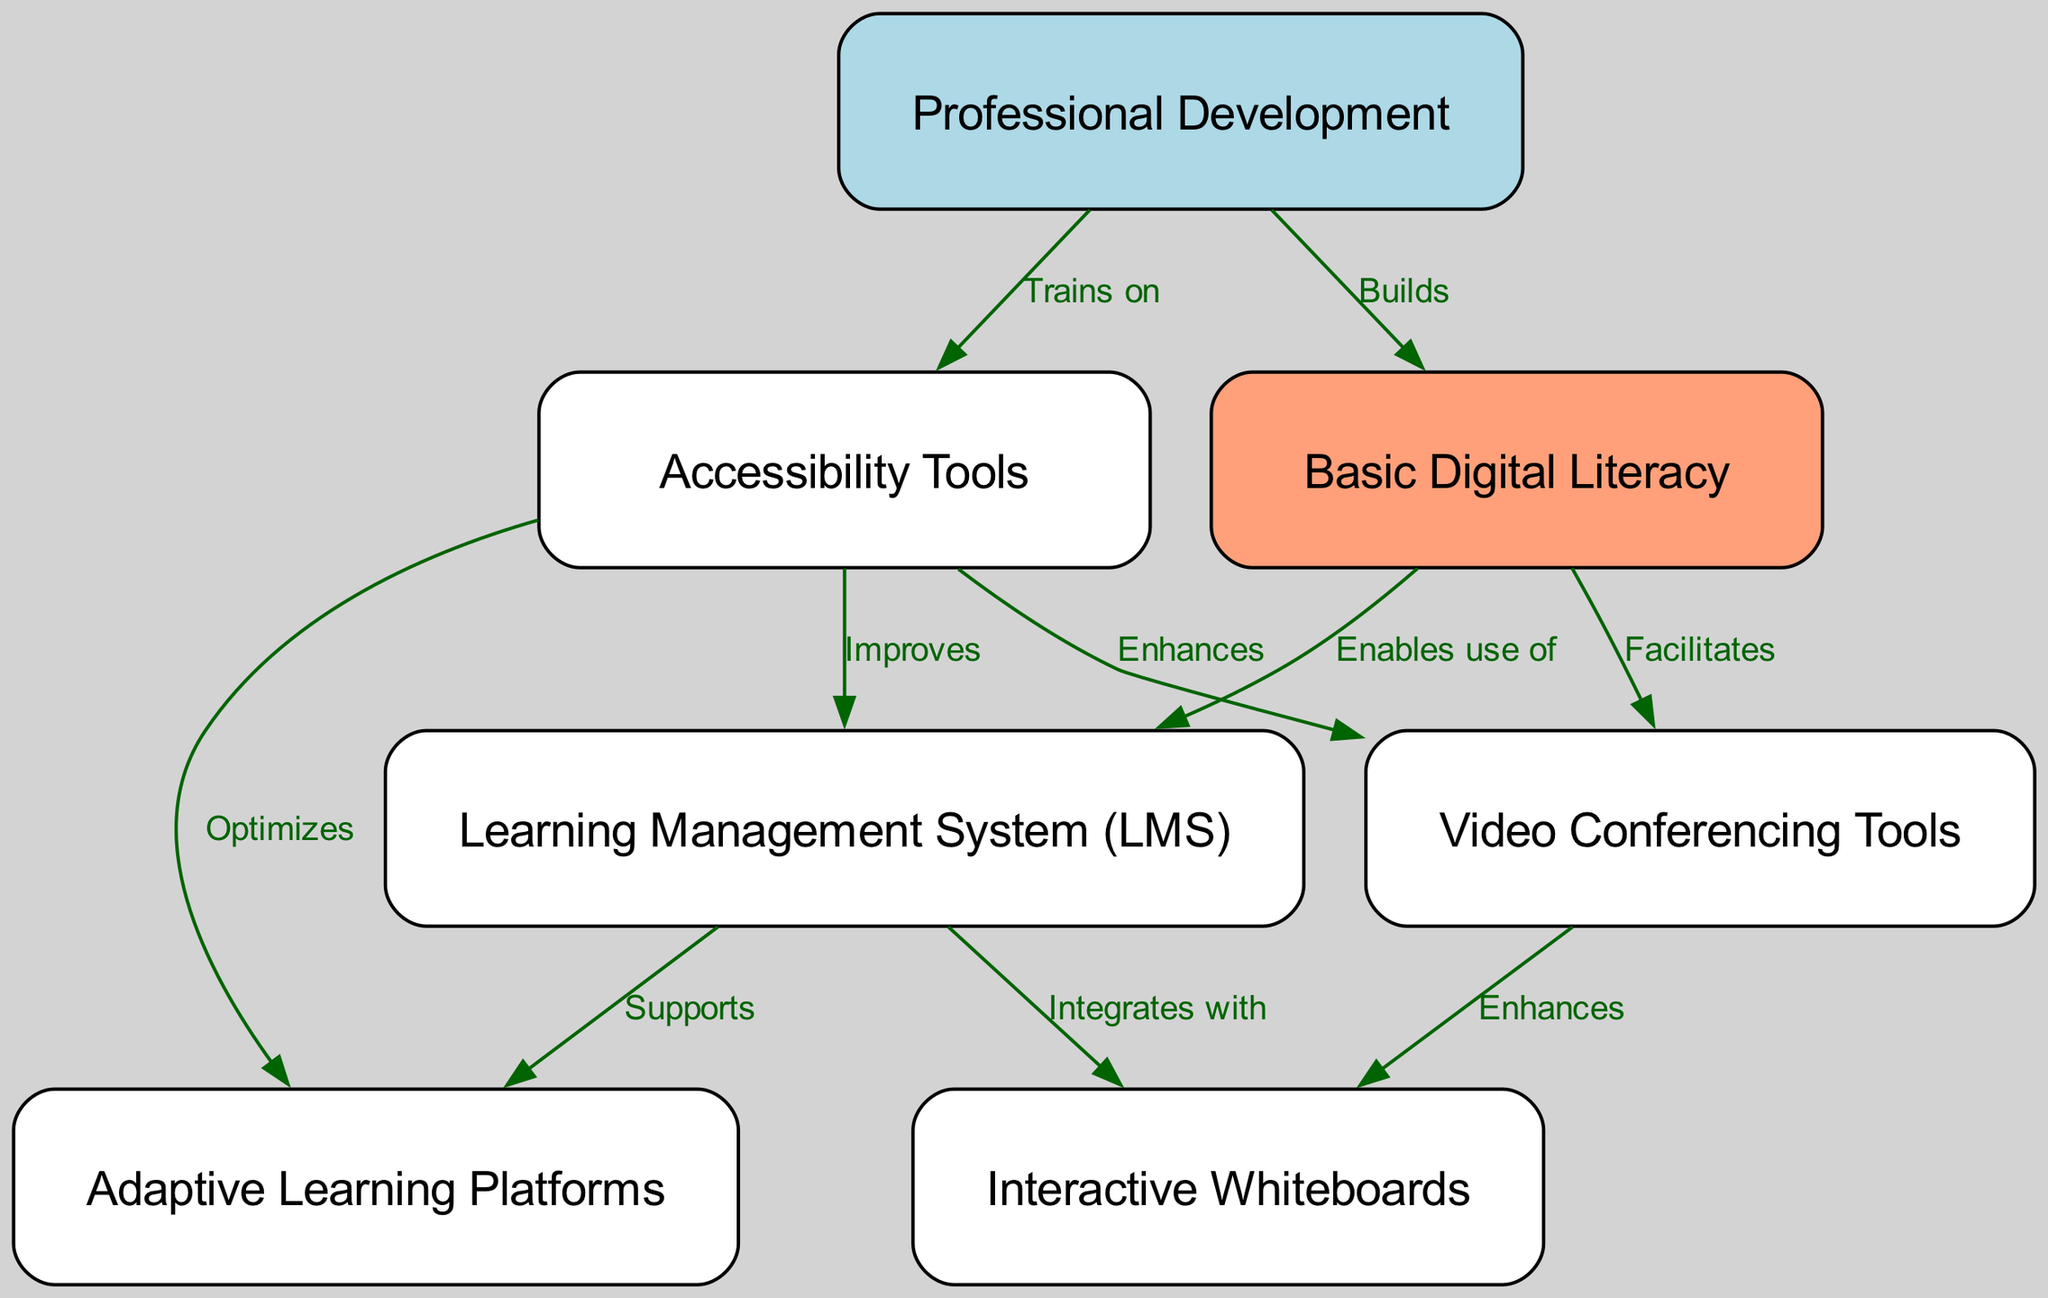What is the first step in the adoption roadmap? The first step in the adoption roadmap is "Basic Digital Literacy," which is shown as the starting node in the diagram.
Answer: Basic Digital Literacy How many nodes are present in the diagram? Counting all distinct nodes listed, there are seven nodes in total in the diagram.
Answer: 7 Which tool integrates with the Learning Management System? "Interactive Whiteboards" integrates with the Learning Management System, as indicated by the directed edge from node 2 to node 4 in the diagram.
Answer: Interactive Whiteboards What does Adaptive Learning Platforms support? The diagram shows that "Adaptive Learning Platforms," represented by node 5, is supported by the Learning Management System (LMS), which is node 2.
Answer: Learning Management System How does Accessibility Tools enhance Video Conferencing Tools? The relationship from Accessibility Tools (node 6) to Video Conferencing Tools (node 3) is depicted as enhancing, indicating that accessibility tools provide improvements for these conferencing tools.
Answer: Enhances What is the role of Professional Development in the adoption roadmap? Professional Development (node 7) builds Basic Digital Literacy (node 1) and trains on Accessibility Tools (node 6), emphasizing its importance in capacity building and training.
Answer: Builds and trains Which node does the Accessibility Tools optimize? The diagram indicates that Accessibility Tools optimize Adaptive Learning Platforms, showing a direct relationship from node 6 to node 5.
Answer: Adaptive Learning Platforms Which tool facilitates Video Conferencing Tools? Basic Digital Literacy (node 1) facilitates Video Conferencing Tools (node 3), indicating that a foundational understanding of technology is necessary for effective use of video tools.
Answer: Basic Digital Literacy What enables the use of Learning Management Systems? The adoption of Learning Management Systems is enabled by Basic Digital Literacy, according to the edge from node 1 to node 2.
Answer: Basic Digital Literacy 